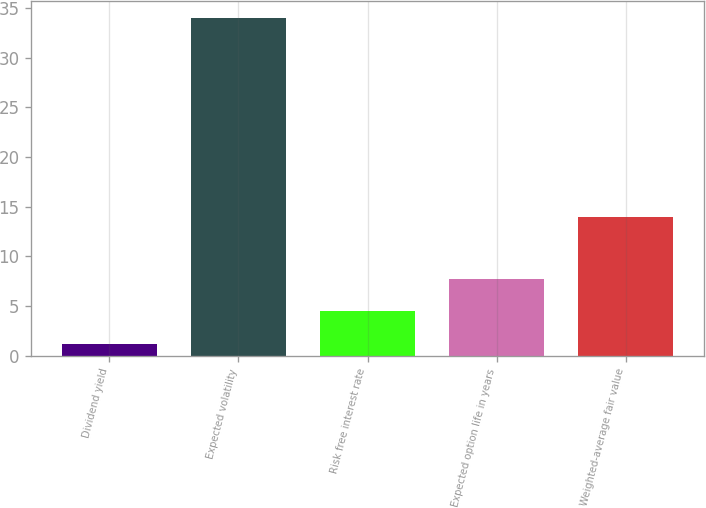Convert chart to OTSL. <chart><loc_0><loc_0><loc_500><loc_500><bar_chart><fcel>Dividend yield<fcel>Expected volatility<fcel>Risk free interest rate<fcel>Expected option life in years<fcel>Weighted-average fair value<nl><fcel>1.2<fcel>34<fcel>4.48<fcel>7.76<fcel>13.92<nl></chart> 